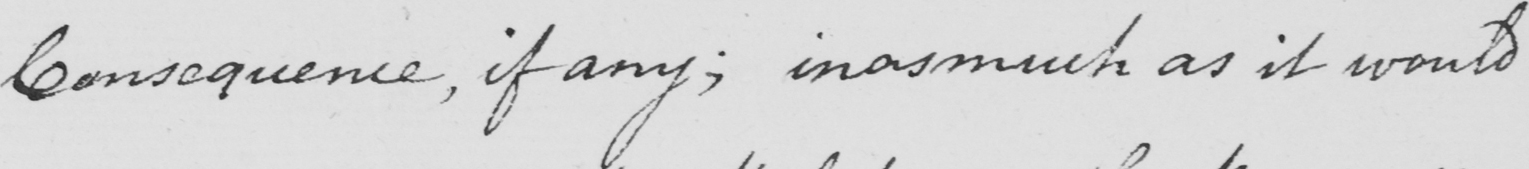What text is written in this handwritten line? Consequence , if any ; in as much as it would 